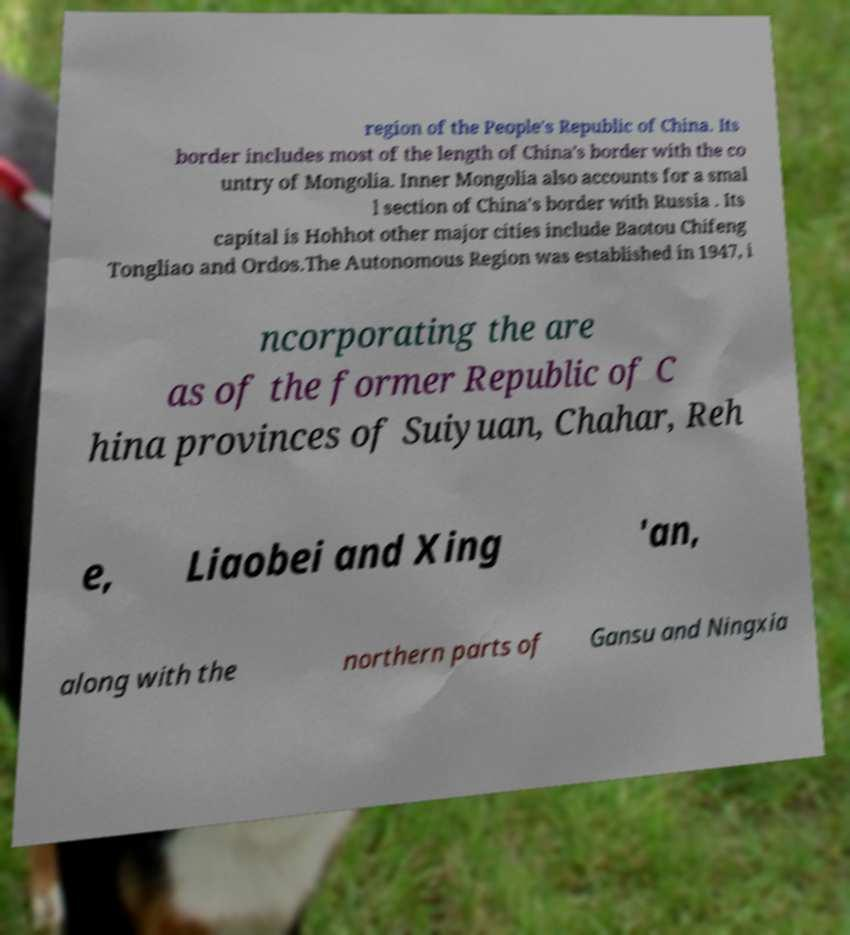What messages or text are displayed in this image? I need them in a readable, typed format. region of the People's Republic of China. Its border includes most of the length of China's border with the co untry of Mongolia. Inner Mongolia also accounts for a smal l section of China's border with Russia . Its capital is Hohhot other major cities include Baotou Chifeng Tongliao and Ordos.The Autonomous Region was established in 1947, i ncorporating the are as of the former Republic of C hina provinces of Suiyuan, Chahar, Reh e, Liaobei and Xing 'an, along with the northern parts of Gansu and Ningxia 